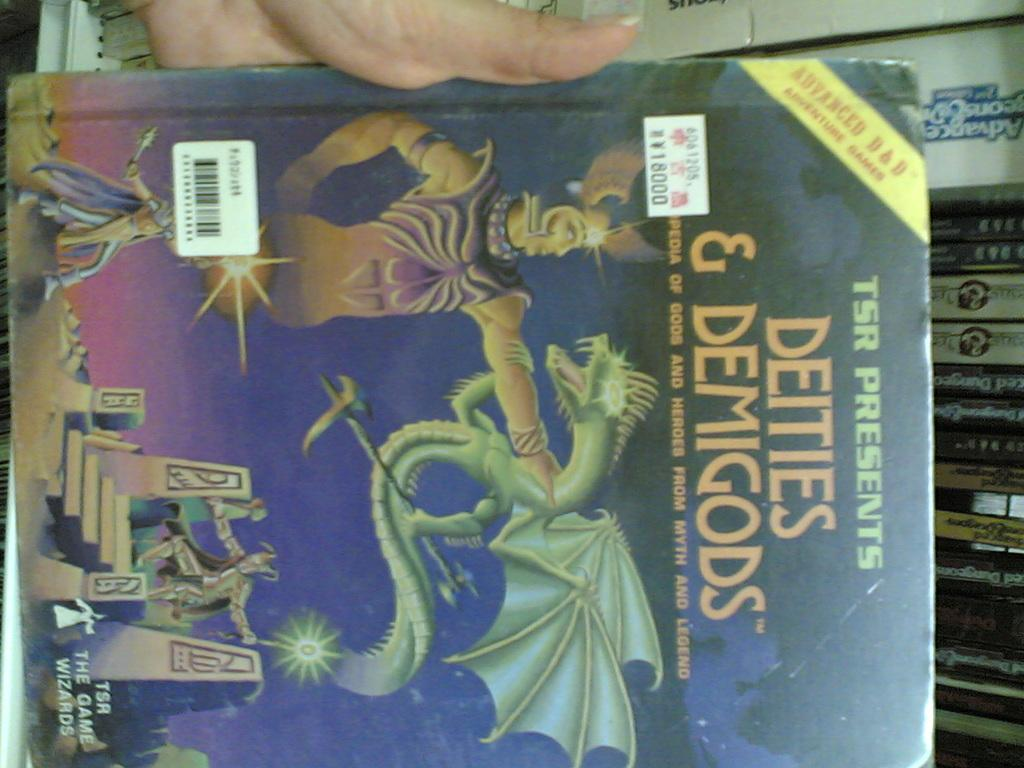<image>
Share a concise interpretation of the image provided. The title of this book is Deities and Demigods. 